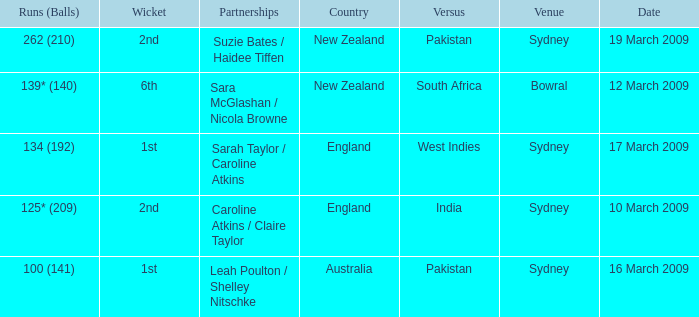What are the dates where the versus team is South Africa? 12 March 2009. 